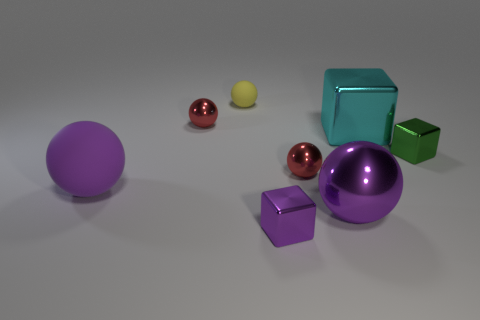Subtract 2 spheres. How many spheres are left? 3 Subtract all big purple metallic balls. How many balls are left? 4 Subtract all yellow balls. How many balls are left? 4 Subtract all gray balls. Subtract all cyan blocks. How many balls are left? 5 Add 1 small purple rubber blocks. How many objects exist? 9 Subtract all cubes. How many objects are left? 5 Subtract all small red balls. Subtract all green things. How many objects are left? 5 Add 2 green shiny things. How many green shiny things are left? 3 Add 6 green rubber things. How many green rubber things exist? 6 Subtract 0 cyan balls. How many objects are left? 8 